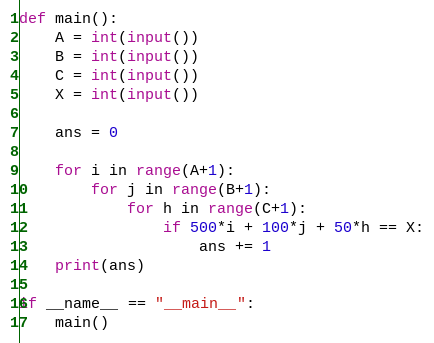Convert code to text. <code><loc_0><loc_0><loc_500><loc_500><_Python_>def main():
    A = int(input())
    B = int(input())
    C = int(input())
    X = int(input())
    
    ans = 0

    for i in range(A+1):
        for j in range(B+1):
            for h in range(C+1):
                if 500*i + 100*j + 50*h == X:
                    ans += 1    
    print(ans)

if __name__ == "__main__":
    main()</code> 